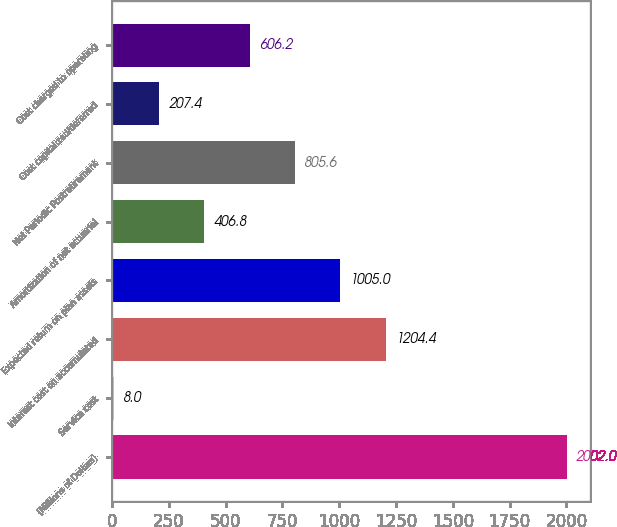Convert chart to OTSL. <chart><loc_0><loc_0><loc_500><loc_500><bar_chart><fcel>(Millions of Dollars)<fcel>Service cost<fcel>Interest cost on accumulated<fcel>Expected return on plan assets<fcel>Amortization of net actuarial<fcel>Net Periodic Postretirement<fcel>Cost capitalized/deferred<fcel>Cost charged to operating<nl><fcel>2002<fcel>8<fcel>1204.4<fcel>1005<fcel>406.8<fcel>805.6<fcel>207.4<fcel>606.2<nl></chart> 